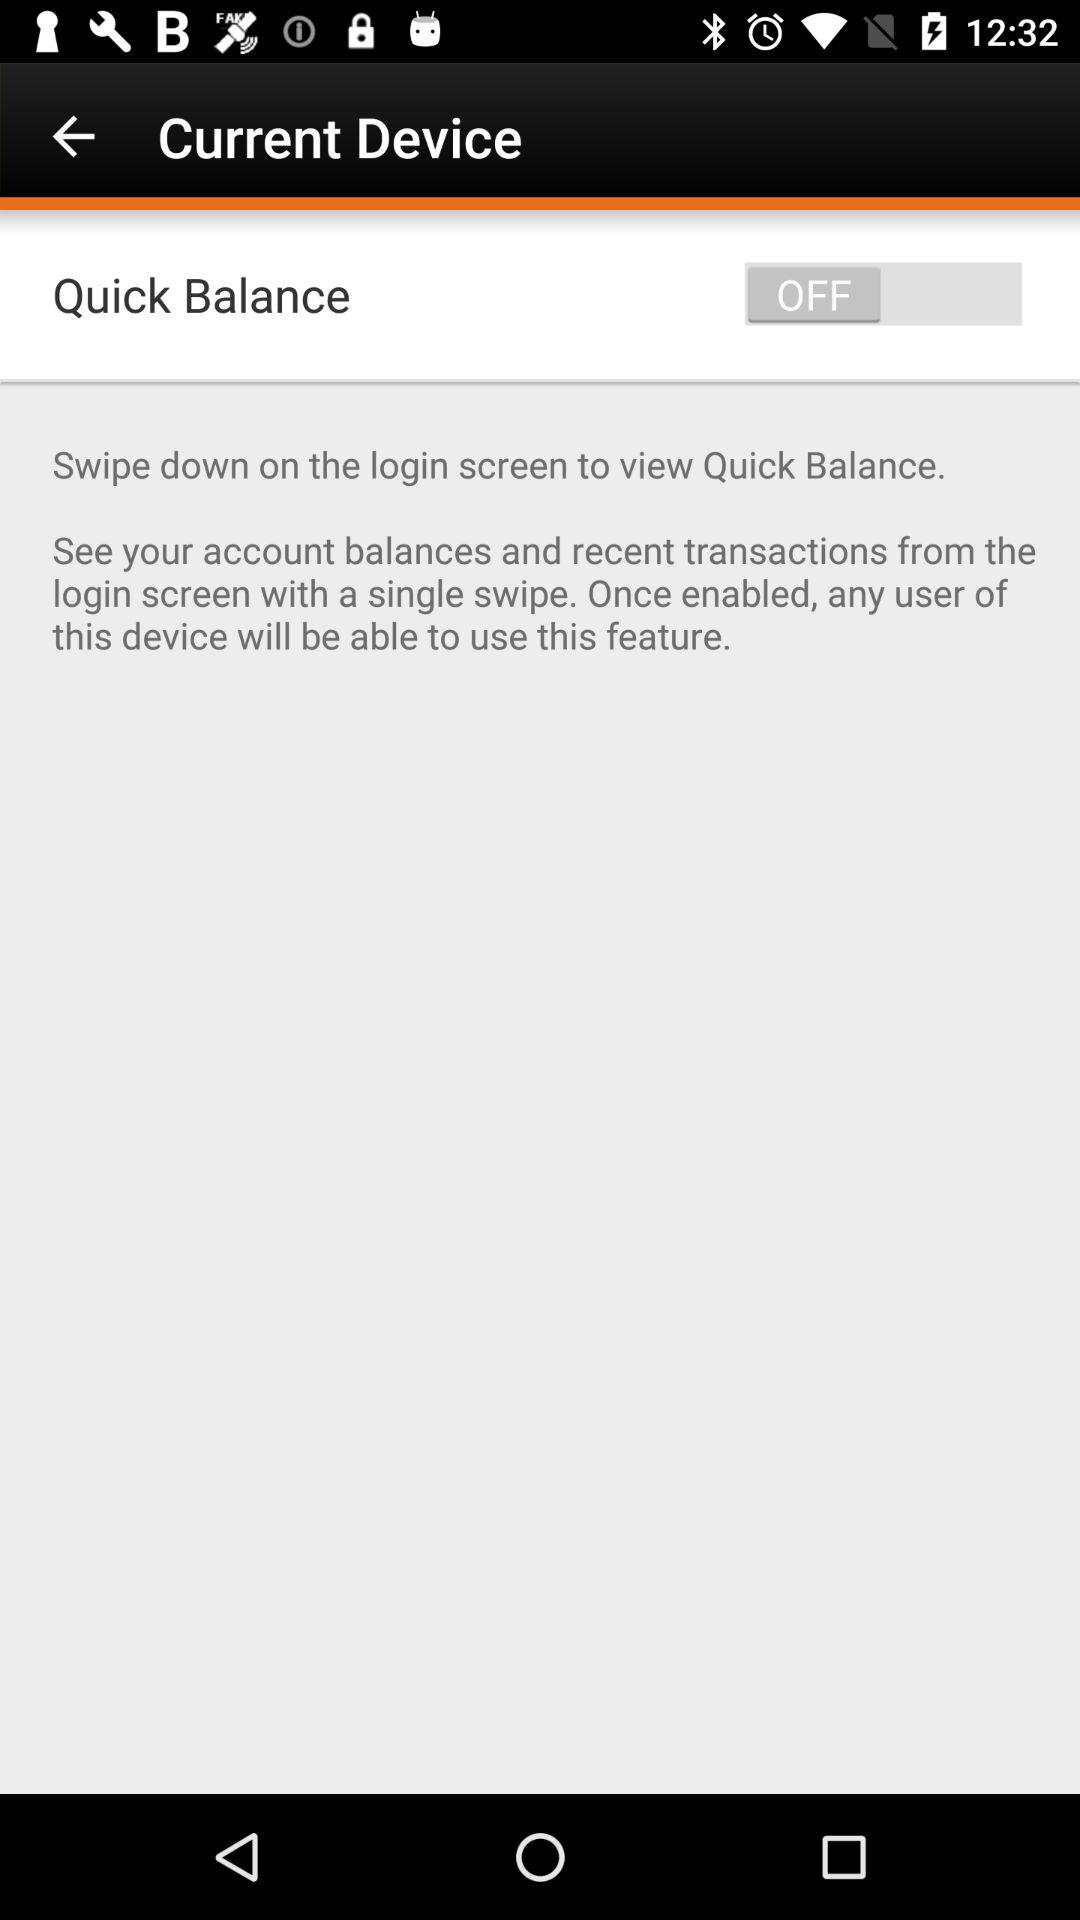What is the status of "Quick Balance"? The status of "Quick Balance" is "off". 